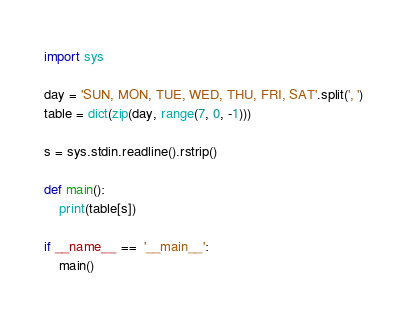Convert code to text. <code><loc_0><loc_0><loc_500><loc_500><_Python_>import sys

day = 'SUN, MON, TUE, WED, THU, FRI, SAT'.split(', ')
table = dict(zip(day, range(7, 0, -1)))

s = sys.stdin.readline().rstrip()

def main():
    print(table[s])

if __name__ ==  '__main__':
    main()</code> 